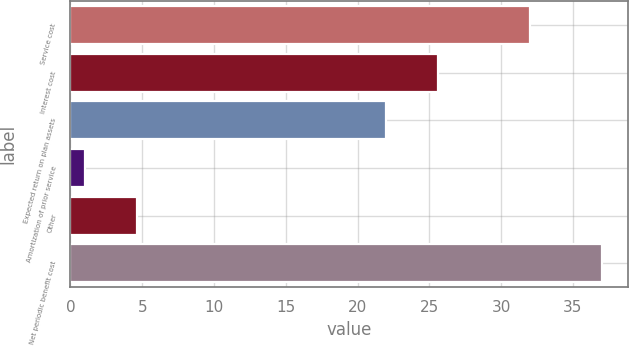<chart> <loc_0><loc_0><loc_500><loc_500><bar_chart><fcel>Service cost<fcel>Interest cost<fcel>Expected return on plan assets<fcel>Amortization of prior service<fcel>Other<fcel>Net periodic benefit cost<nl><fcel>32<fcel>25.6<fcel>22<fcel>1<fcel>4.6<fcel>37<nl></chart> 